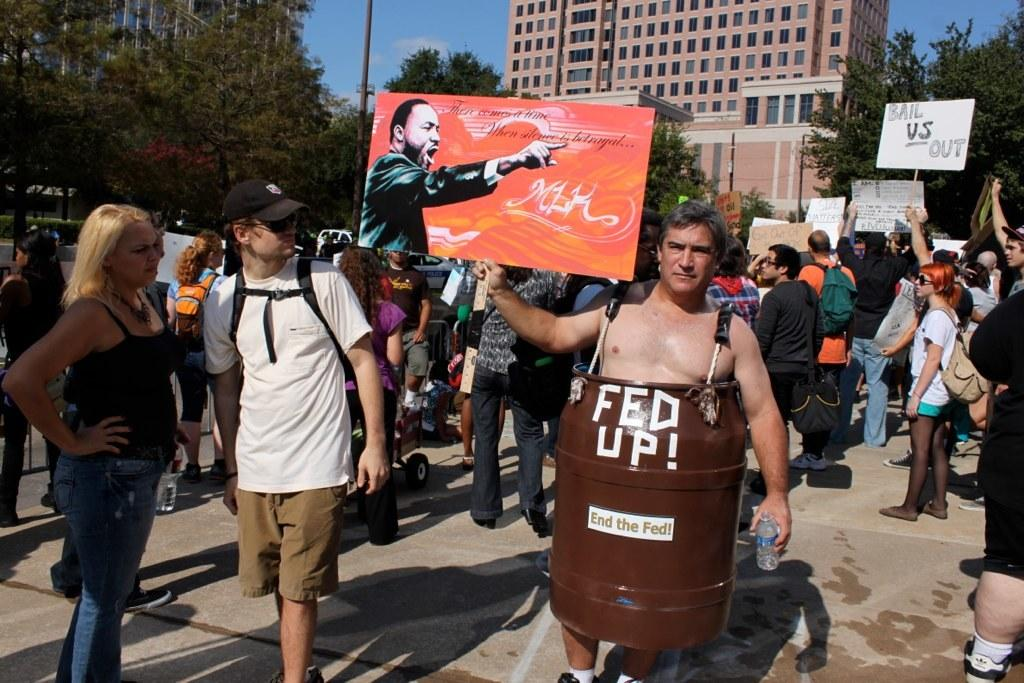What can be seen in the foreground of the image? There are people in the foreground area of the image. What are the people holding in their hands? The people are holding posters in their hands. What can be seen in the background of the image? There are trees, buildings, vehicles, a pole, and the sky visible in the background area of the image. What type of musical instrument is being played by the people in the image? There is no musical instrument visible in the image; the people are holding posters. How does the earth appear in the image? The image does not show the earth as a whole; it only shows a portion of the ground and the sky. 